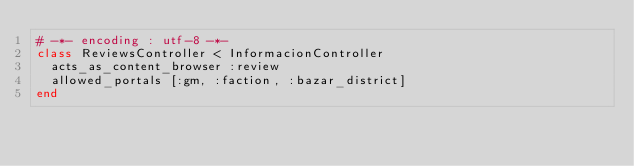<code> <loc_0><loc_0><loc_500><loc_500><_Ruby_># -*- encoding : utf-8 -*-
class ReviewsController < InformacionController
  acts_as_content_browser :review
  allowed_portals [:gm, :faction, :bazar_district]
end
</code> 